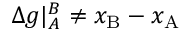Convert formula to latex. <formula><loc_0><loc_0><loc_500><loc_500>\Delta g | _ { A } ^ { B } \neq x _ { B } - x _ { A }</formula> 